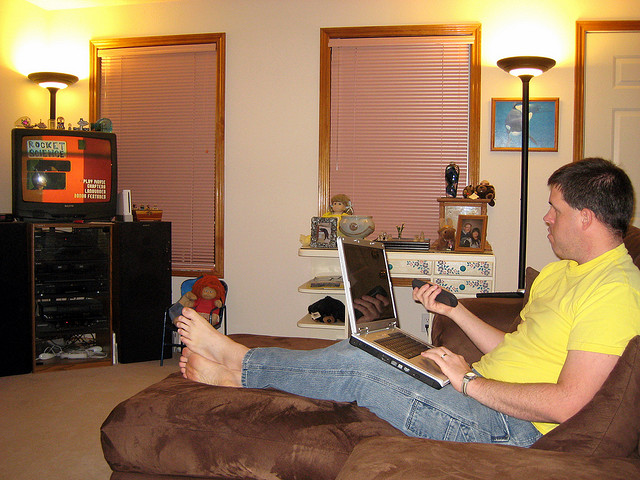How many young elephants are shown? The image does not show any elephants. It depicts a person seated on a couch using a laptop with a room visible in the background featuring a television, blinds, and some personal items on the shelves. 